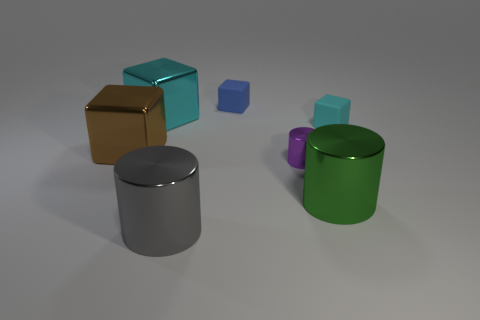What is the size of the cylinder behind the green thing?
Your answer should be compact. Small. What number of blue things have the same size as the brown cube?
Your response must be concise. 0. The block that is both to the right of the large gray thing and left of the purple cylinder is made of what material?
Keep it short and to the point. Rubber. What is the material of the gray cylinder that is the same size as the cyan metal cube?
Offer a very short reply. Metal. There is a cyan object to the right of the tiny object that is behind the metal thing that is behind the brown shiny block; how big is it?
Ensure brevity in your answer.  Small. What size is the purple cylinder that is made of the same material as the brown thing?
Offer a very short reply. Small. Is the size of the green shiny cylinder the same as the cyan cube that is to the left of the small cyan block?
Your response must be concise. Yes. There is a object that is on the right side of the green shiny thing; what is its shape?
Provide a succinct answer. Cube. There is a tiny rubber thing that is behind the rubber block right of the tiny blue matte thing; are there any small purple shiny cylinders that are to the left of it?
Offer a terse response. No. There is a small cyan thing that is the same shape as the big cyan thing; what material is it?
Make the answer very short. Rubber. 